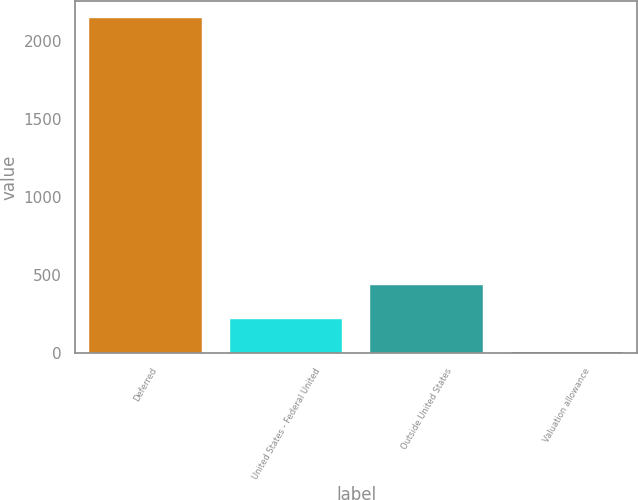Convert chart. <chart><loc_0><loc_0><loc_500><loc_500><bar_chart><fcel>Deferred<fcel>United States - Federal United<fcel>Outside United States<fcel>Valuation allowance<nl><fcel>2149<fcel>220.3<fcel>434.6<fcel>6<nl></chart> 